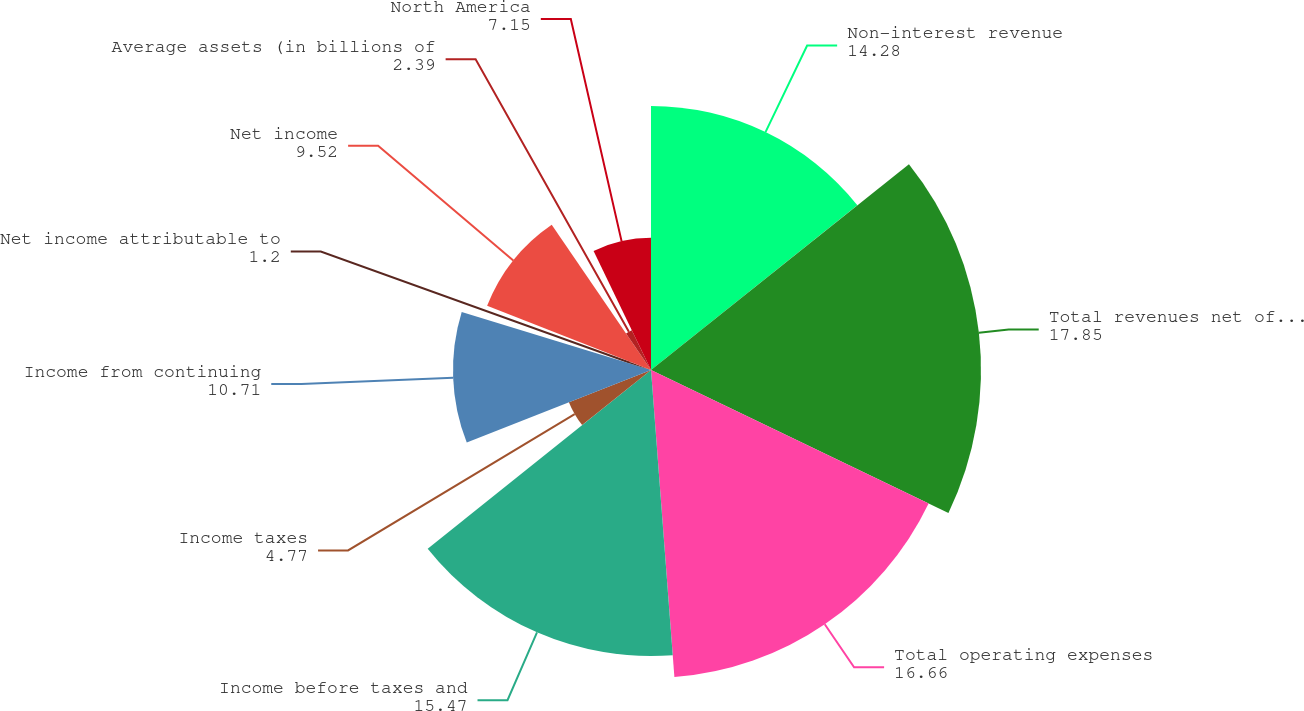Convert chart to OTSL. <chart><loc_0><loc_0><loc_500><loc_500><pie_chart><fcel>Non-interest revenue<fcel>Total revenues net of interest<fcel>Total operating expenses<fcel>Income before taxes and<fcel>Income taxes<fcel>Income from continuing<fcel>Net income attributable to<fcel>Net income<fcel>Average assets (in billions of<fcel>North America<nl><fcel>14.28%<fcel>17.85%<fcel>16.66%<fcel>15.47%<fcel>4.77%<fcel>10.71%<fcel>1.2%<fcel>9.52%<fcel>2.39%<fcel>7.15%<nl></chart> 